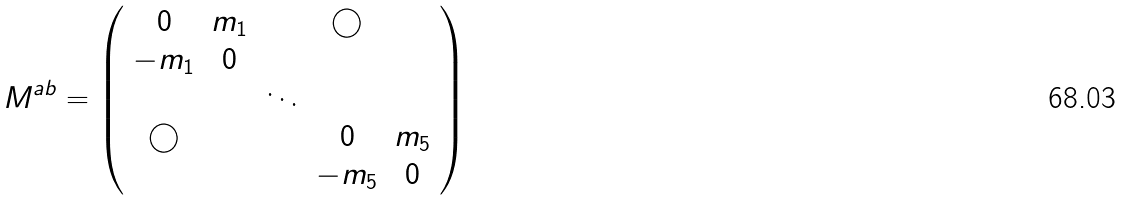<formula> <loc_0><loc_0><loc_500><loc_500>M ^ { a b } = \left ( \begin{array} { c c c c c } 0 & m _ { 1 } & & \bigcirc & \\ - m _ { 1 } & 0 & & & \\ & & \ddots & & \\ \bigcirc & & & 0 & m _ { 5 } \\ & & & - m _ { 5 } & 0 \end{array} \right )</formula> 